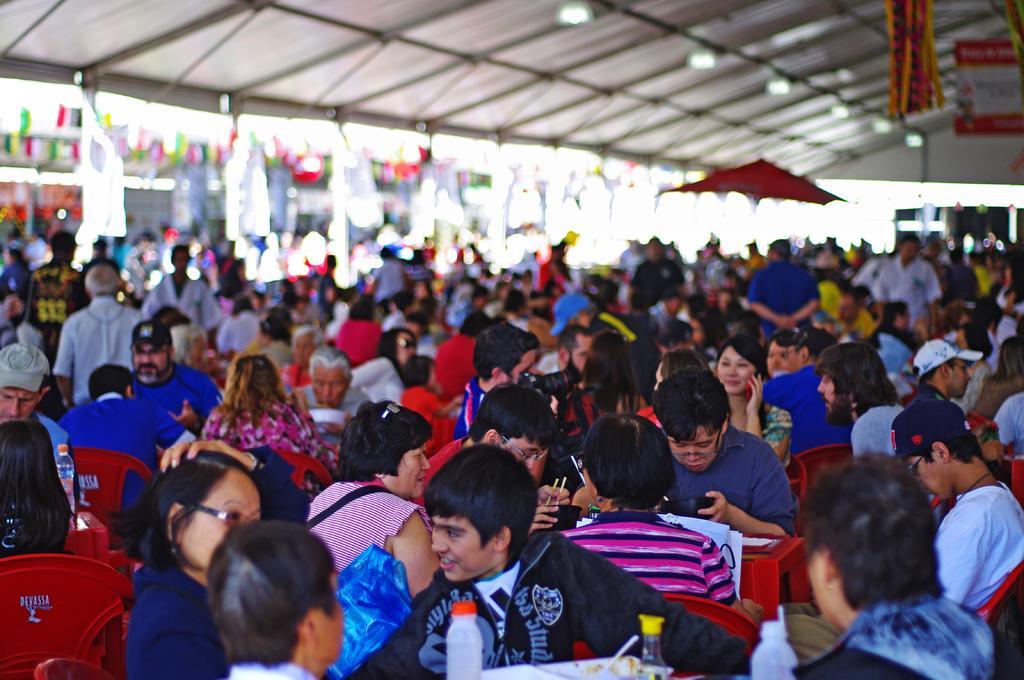Can you describe this image briefly? In this image we can see a group of people sitting on the chairs. In that some are holding the bowls. On the backside we can see a group of people standing and a roof with some ceiling lights. 